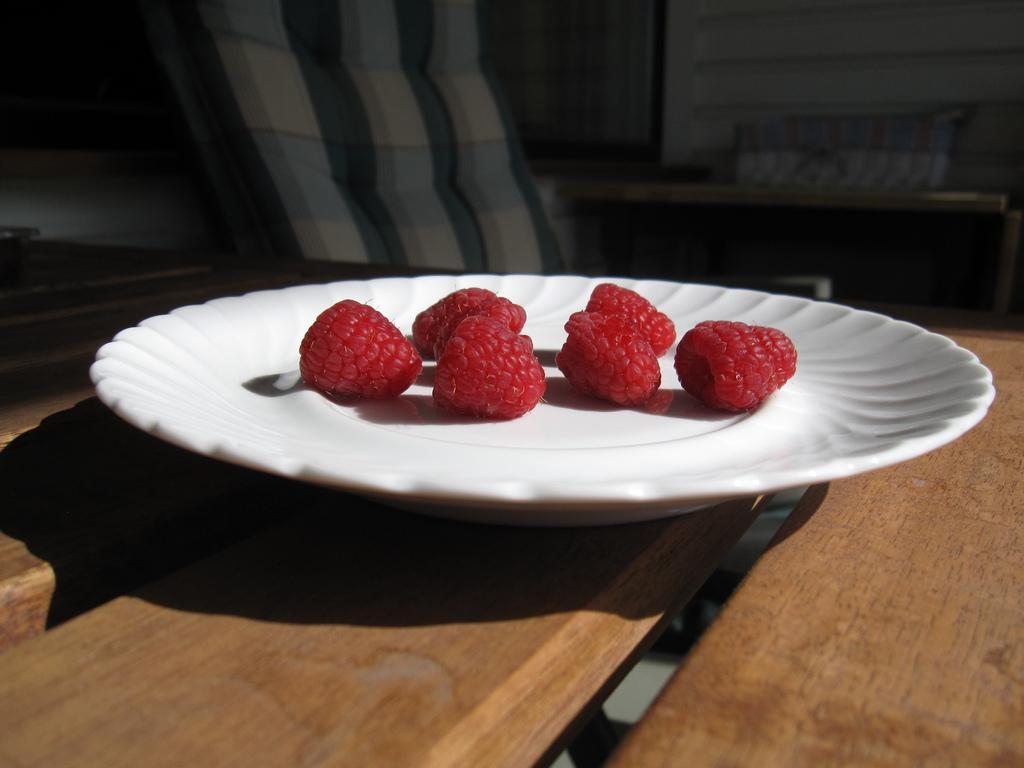In one or two sentences, can you explain what this image depicts? As we can see in the image there is a table, chair and a wall. On table there is a plate. In plate there are strawberries. 